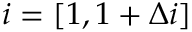<formula> <loc_0><loc_0><loc_500><loc_500>i = [ 1 , { 1 + \Delta i } ]</formula> 